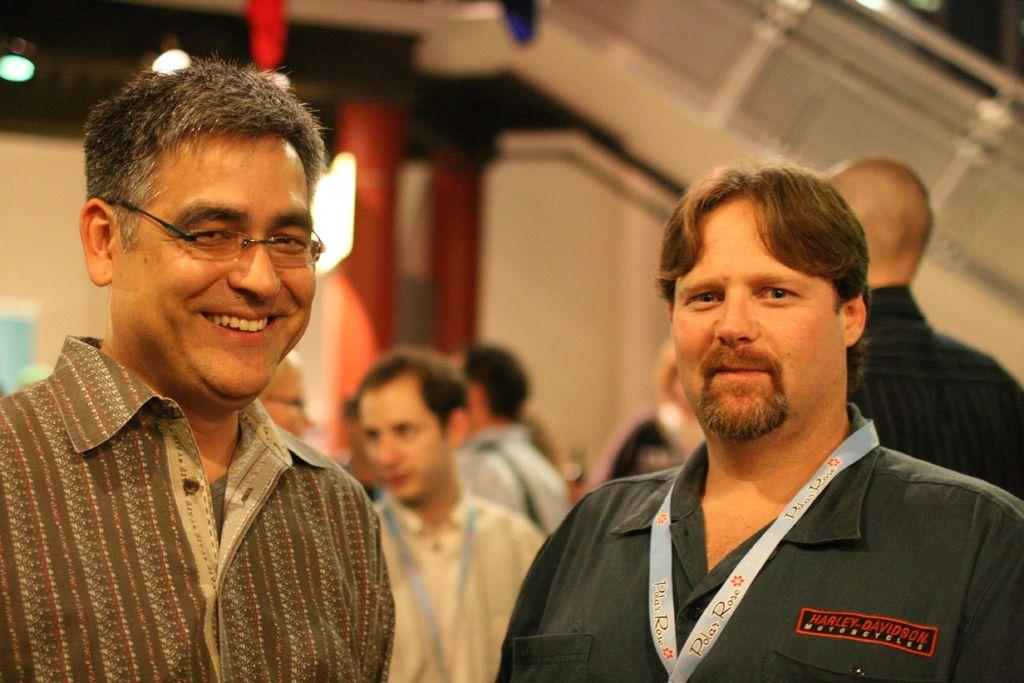How many men are present in the image? There are four men in the image, two on the right side and two on the left side. What can be seen in the background of the image? In the background of the image, there is a group of people, pillars, a staircase, and a wall. Can you describe the setting of the image? The image appears to be set in a large, open space with pillars and a staircase in the background. What type of paint is being used by the men in the image? There is no paint or painting activity visible in the image. Can you describe the picture hanging on the wall in the image? There is no picture hanging on the wall in the image; only pillars and a staircase are visible in the background. 